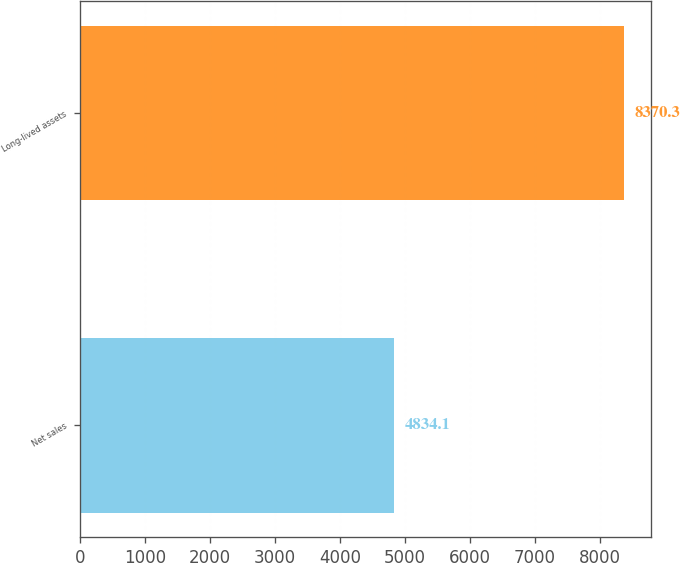Convert chart. <chart><loc_0><loc_0><loc_500><loc_500><bar_chart><fcel>Net sales<fcel>Long-lived assets<nl><fcel>4834.1<fcel>8370.3<nl></chart> 